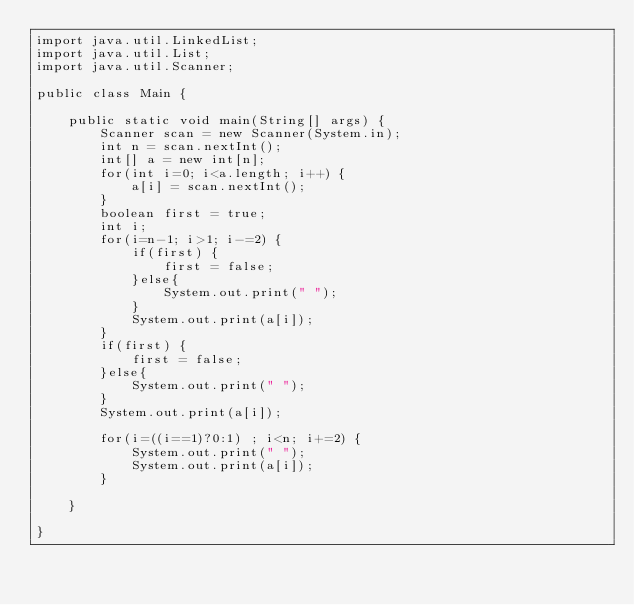Convert code to text. <code><loc_0><loc_0><loc_500><loc_500><_Java_>import java.util.LinkedList;
import java.util.List;
import java.util.Scanner;

public class Main {

	public static void main(String[] args) {
		Scanner scan = new Scanner(System.in);
		int n = scan.nextInt();
		int[] a = new int[n];
		for(int i=0; i<a.length; i++) {
			a[i] = scan.nextInt();
		}
		boolean first = true;
		int i;
		for(i=n-1; i>1; i-=2) {
			if(first) {
				first = false;
			}else{
				System.out.print(" ");
			}
			System.out.print(a[i]);
		}
		if(first) {
			first = false;
		}else{
			System.out.print(" ");
		}
		System.out.print(a[i]);
		
		for(i=((i==1)?0:1) ; i<n; i+=2) {
			System.out.print(" ");
			System.out.print(a[i]);
		}
		
	}

}
</code> 